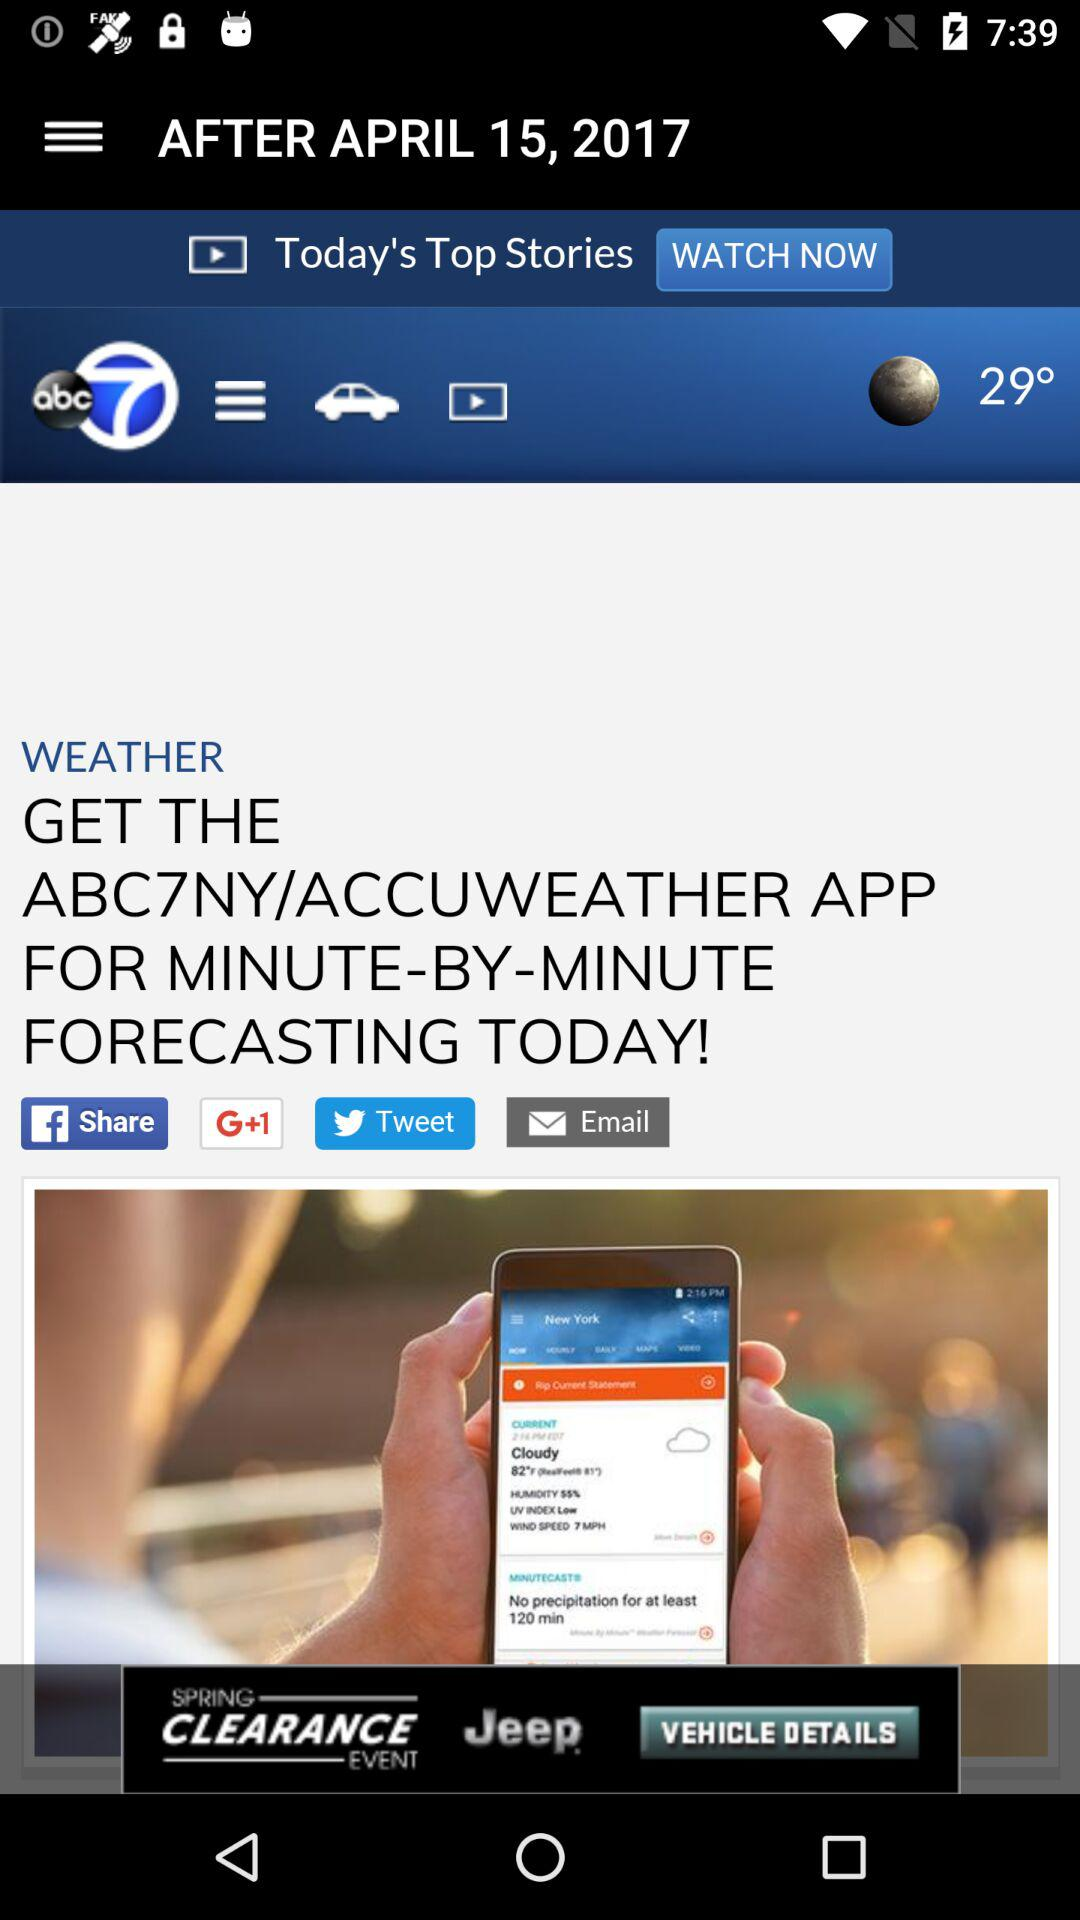What is the temperature? The temperature is 29 degrees. 